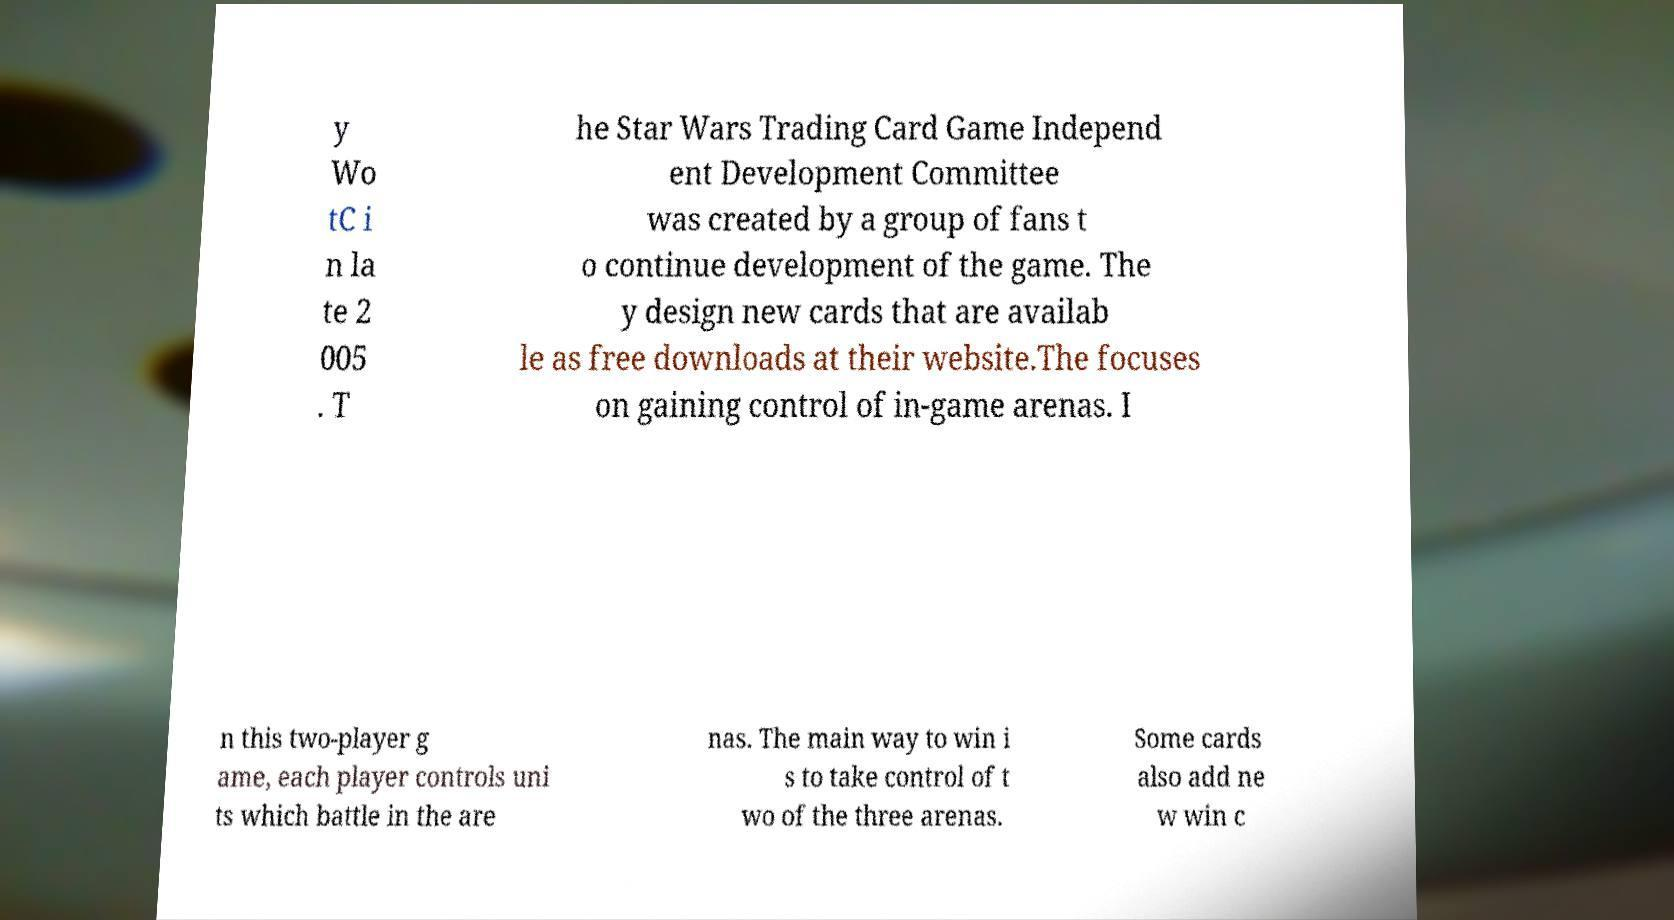Please identify and transcribe the text found in this image. y Wo tC i n la te 2 005 . T he Star Wars Trading Card Game Independ ent Development Committee was created by a group of fans t o continue development of the game. The y design new cards that are availab le as free downloads at their website.The focuses on gaining control of in-game arenas. I n this two-player g ame, each player controls uni ts which battle in the are nas. The main way to win i s to take control of t wo of the three arenas. Some cards also add ne w win c 